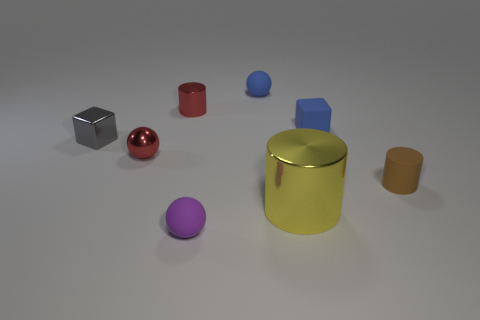Add 1 small red matte cubes. How many objects exist? 9 Subtract all cylinders. How many objects are left? 5 Subtract 1 yellow cylinders. How many objects are left? 7 Subtract all purple balls. Subtract all red balls. How many objects are left? 6 Add 8 small red things. How many small red things are left? 10 Add 3 big gray shiny blocks. How many big gray shiny blocks exist? 3 